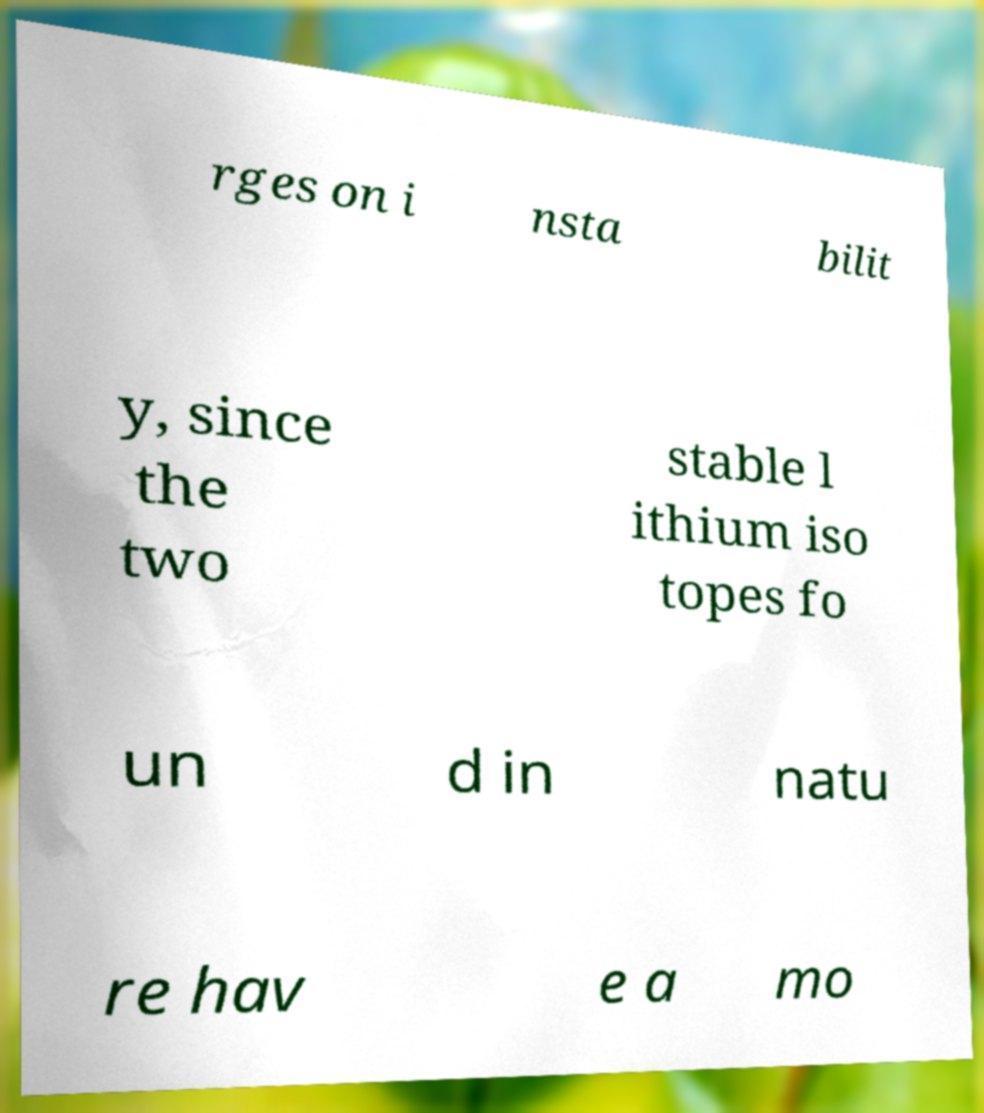There's text embedded in this image that I need extracted. Can you transcribe it verbatim? rges on i nsta bilit y, since the two stable l ithium iso topes fo un d in natu re hav e a mo 